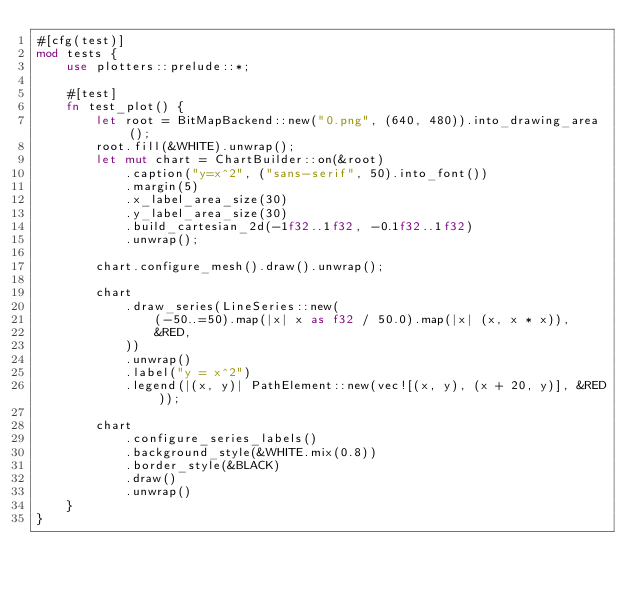Convert code to text. <code><loc_0><loc_0><loc_500><loc_500><_Rust_>#[cfg(test)]
mod tests {
    use plotters::prelude::*;

    #[test]
    fn test_plot() {
        let root = BitMapBackend::new("0.png", (640, 480)).into_drawing_area();
        root.fill(&WHITE).unwrap();
        let mut chart = ChartBuilder::on(&root)
            .caption("y=x^2", ("sans-serif", 50).into_font())
            .margin(5)
            .x_label_area_size(30)
            .y_label_area_size(30)
            .build_cartesian_2d(-1f32..1f32, -0.1f32..1f32)
            .unwrap();

        chart.configure_mesh().draw().unwrap();

        chart
            .draw_series(LineSeries::new(
                (-50..=50).map(|x| x as f32 / 50.0).map(|x| (x, x * x)),
                &RED,
            ))
            .unwrap()
            .label("y = x^2")
            .legend(|(x, y)| PathElement::new(vec![(x, y), (x + 20, y)], &RED));

        chart
            .configure_series_labels()
            .background_style(&WHITE.mix(0.8))
            .border_style(&BLACK)
            .draw()
            .unwrap()
    }
}
</code> 